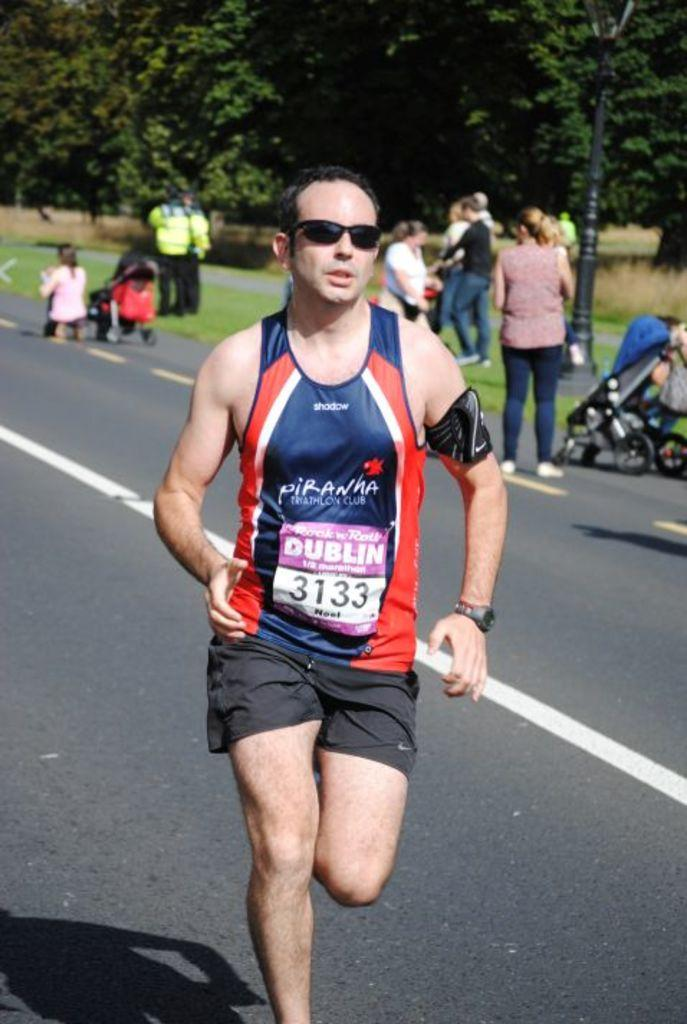What is the man in the image wearing? The man in the image is wearing shorts and sportswear. Can you describe the background of the image? There are people in the background of the image, as well as a street light and trees. How many people are visible in the background? The number of people in the background is not specified, but there are at least some people visible. What type of jar is being used to catch the birds in the image? There is no jar or birds present in the image. 